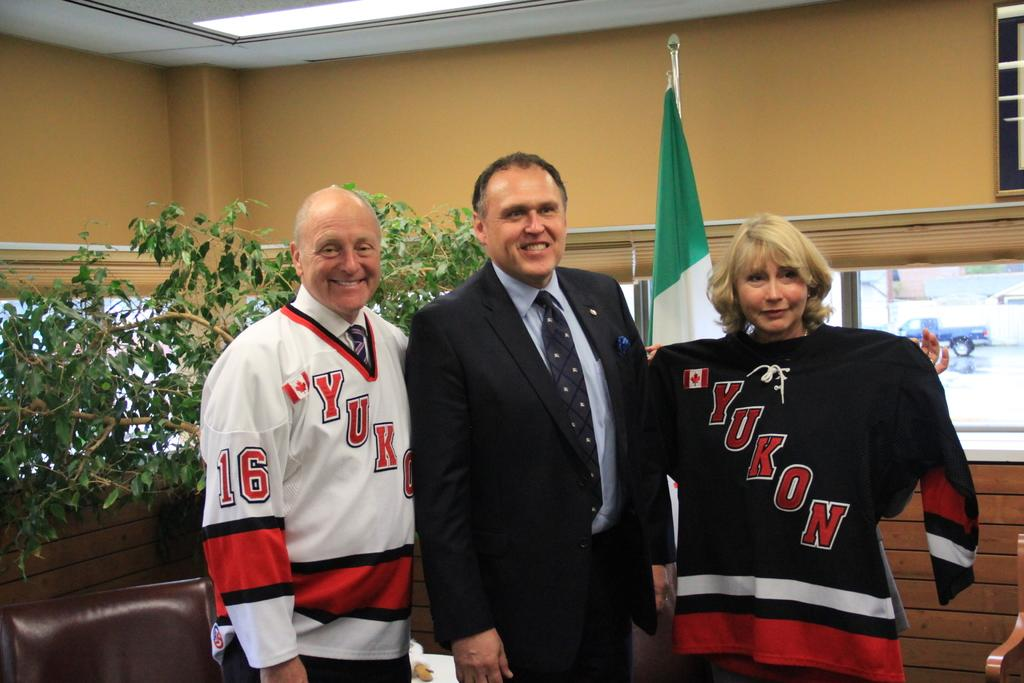<image>
Give a short and clear explanation of the subsequent image. A man in a suit is posing with a man and woman in Yukon jerseys. 